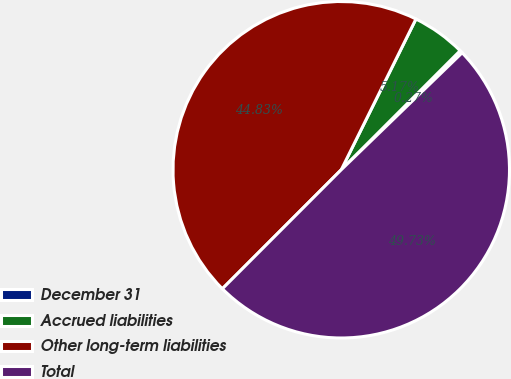<chart> <loc_0><loc_0><loc_500><loc_500><pie_chart><fcel>December 31<fcel>Accrued liabilities<fcel>Other long-term liabilities<fcel>Total<nl><fcel>0.27%<fcel>5.17%<fcel>44.83%<fcel>49.73%<nl></chart> 